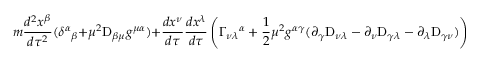<formula> <loc_0><loc_0><loc_500><loc_500>m { \frac { d ^ { 2 } x ^ { \beta } } { d \tau ^ { 2 } } } ( \delta ^ { \alpha _ { \beta } + \mu ^ { 2 } D _ { \beta \mu } g ^ { \mu \alpha } ) + { \frac { d x ^ { \nu } } { d \tau } } { \frac { d x ^ { \lambda } } { d \tau } } \left ( \Gamma _ { \nu \lambda ^ { \alpha } + \frac { 1 } { 2 } \mu ^ { 2 } g ^ { \alpha \gamma } ( \partial _ { \gamma } D _ { \nu \lambda } - \partial _ { \nu } D _ { \gamma \lambda } - \partial _ { \lambda } D _ { \gamma \nu } ) \right ) = 0 ,</formula> 